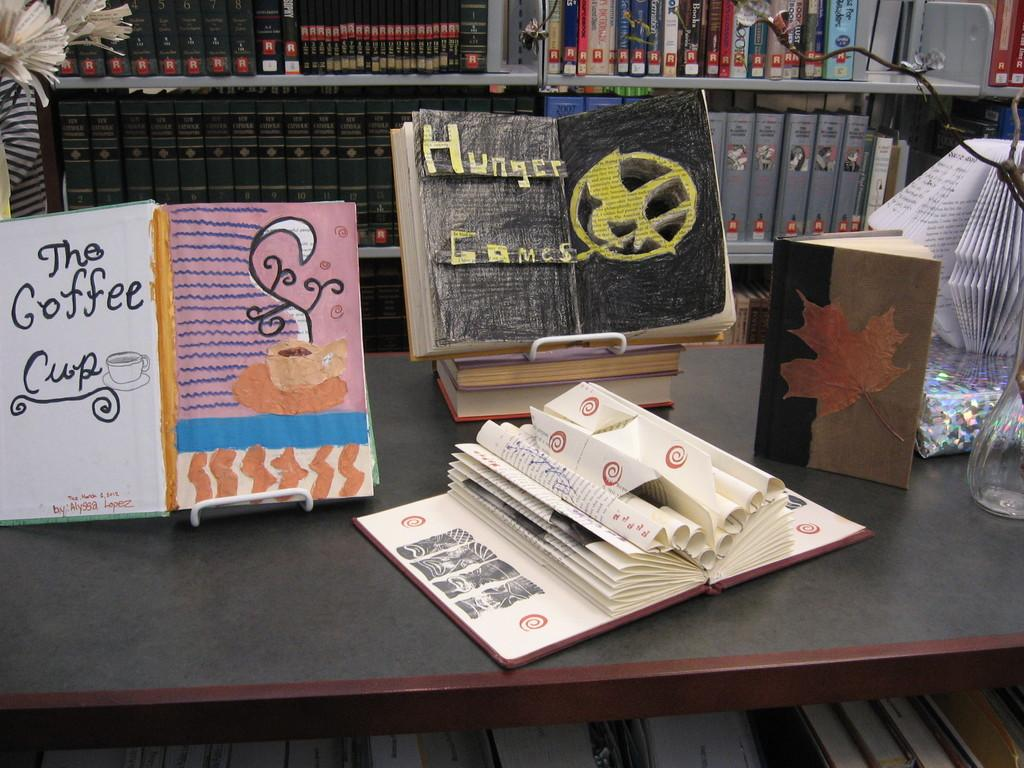<image>
Share a concise interpretation of the image provided. The coffee cup book on a table beside the hunger games book. 